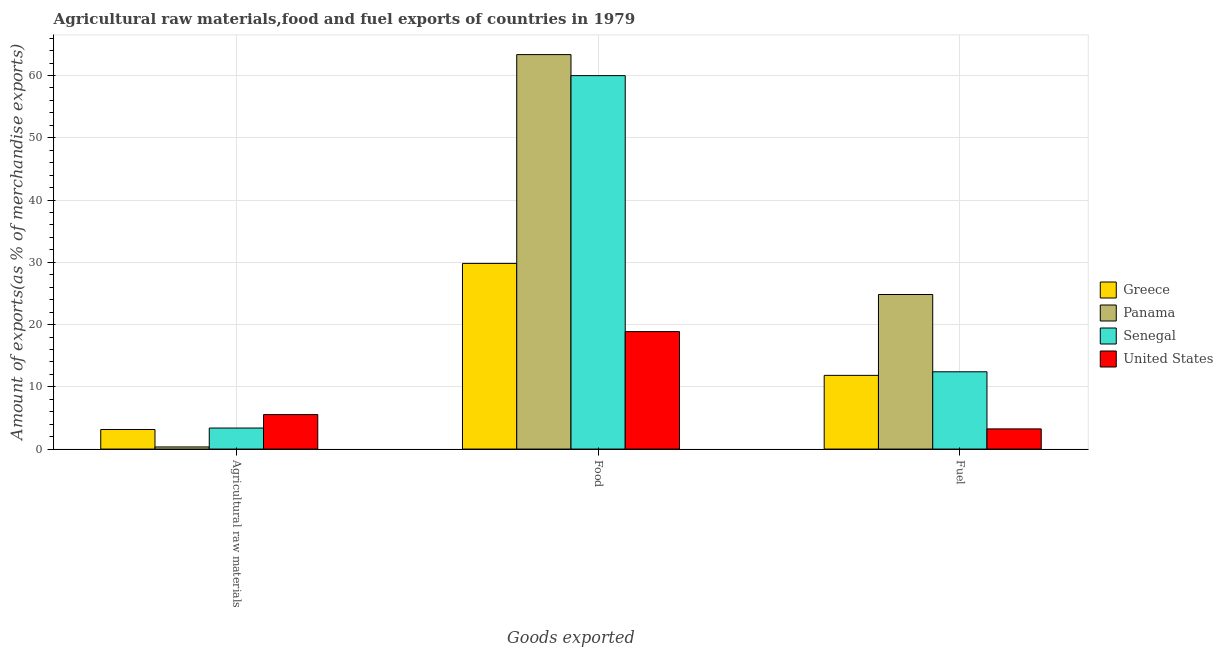How many different coloured bars are there?
Offer a very short reply. 4. Are the number of bars per tick equal to the number of legend labels?
Your answer should be compact. Yes. Are the number of bars on each tick of the X-axis equal?
Your answer should be compact. Yes. How many bars are there on the 2nd tick from the left?
Your answer should be very brief. 4. How many bars are there on the 3rd tick from the right?
Your answer should be compact. 4. What is the label of the 3rd group of bars from the left?
Provide a succinct answer. Fuel. What is the percentage of food exports in Greece?
Provide a short and direct response. 29.82. Across all countries, what is the maximum percentage of food exports?
Provide a short and direct response. 63.36. Across all countries, what is the minimum percentage of raw materials exports?
Offer a very short reply. 0.34. In which country was the percentage of fuel exports maximum?
Offer a very short reply. Panama. In which country was the percentage of food exports minimum?
Provide a succinct answer. United States. What is the total percentage of raw materials exports in the graph?
Keep it short and to the point. 12.4. What is the difference between the percentage of food exports in Panama and that in United States?
Keep it short and to the point. 44.49. What is the difference between the percentage of food exports in United States and the percentage of fuel exports in Greece?
Provide a succinct answer. 7.03. What is the average percentage of raw materials exports per country?
Give a very brief answer. 3.1. What is the difference between the percentage of fuel exports and percentage of raw materials exports in Greece?
Ensure brevity in your answer.  8.69. In how many countries, is the percentage of raw materials exports greater than 32 %?
Offer a very short reply. 0. What is the ratio of the percentage of raw materials exports in United States to that in Greece?
Make the answer very short. 1.76. Is the percentage of raw materials exports in Greece less than that in United States?
Offer a very short reply. Yes. What is the difference between the highest and the second highest percentage of fuel exports?
Your answer should be compact. 12.42. What is the difference between the highest and the lowest percentage of food exports?
Provide a short and direct response. 44.49. Is the sum of the percentage of fuel exports in Senegal and Greece greater than the maximum percentage of raw materials exports across all countries?
Provide a succinct answer. Yes. What does the 2nd bar from the left in Fuel represents?
Ensure brevity in your answer.  Panama. What does the 4th bar from the right in Fuel represents?
Your answer should be compact. Greece. How many countries are there in the graph?
Offer a very short reply. 4. Are the values on the major ticks of Y-axis written in scientific E-notation?
Provide a succinct answer. No. How are the legend labels stacked?
Provide a short and direct response. Vertical. What is the title of the graph?
Keep it short and to the point. Agricultural raw materials,food and fuel exports of countries in 1979. What is the label or title of the X-axis?
Your response must be concise. Goods exported. What is the label or title of the Y-axis?
Make the answer very short. Amount of exports(as % of merchandise exports). What is the Amount of exports(as % of merchandise exports) in Greece in Agricultural raw materials?
Your response must be concise. 3.14. What is the Amount of exports(as % of merchandise exports) of Panama in Agricultural raw materials?
Offer a very short reply. 0.34. What is the Amount of exports(as % of merchandise exports) in Senegal in Agricultural raw materials?
Your answer should be compact. 3.38. What is the Amount of exports(as % of merchandise exports) of United States in Agricultural raw materials?
Provide a short and direct response. 5.54. What is the Amount of exports(as % of merchandise exports) in Greece in Food?
Offer a terse response. 29.82. What is the Amount of exports(as % of merchandise exports) of Panama in Food?
Ensure brevity in your answer.  63.36. What is the Amount of exports(as % of merchandise exports) in Senegal in Food?
Ensure brevity in your answer.  59.98. What is the Amount of exports(as % of merchandise exports) of United States in Food?
Make the answer very short. 18.87. What is the Amount of exports(as % of merchandise exports) of Greece in Fuel?
Provide a succinct answer. 11.84. What is the Amount of exports(as % of merchandise exports) of Panama in Fuel?
Ensure brevity in your answer.  24.83. What is the Amount of exports(as % of merchandise exports) of Senegal in Fuel?
Keep it short and to the point. 12.41. What is the Amount of exports(as % of merchandise exports) in United States in Fuel?
Offer a terse response. 3.24. Across all Goods exported, what is the maximum Amount of exports(as % of merchandise exports) in Greece?
Provide a short and direct response. 29.82. Across all Goods exported, what is the maximum Amount of exports(as % of merchandise exports) of Panama?
Ensure brevity in your answer.  63.36. Across all Goods exported, what is the maximum Amount of exports(as % of merchandise exports) in Senegal?
Offer a terse response. 59.98. Across all Goods exported, what is the maximum Amount of exports(as % of merchandise exports) in United States?
Offer a very short reply. 18.87. Across all Goods exported, what is the minimum Amount of exports(as % of merchandise exports) of Greece?
Offer a very short reply. 3.14. Across all Goods exported, what is the minimum Amount of exports(as % of merchandise exports) of Panama?
Offer a terse response. 0.34. Across all Goods exported, what is the minimum Amount of exports(as % of merchandise exports) in Senegal?
Make the answer very short. 3.38. Across all Goods exported, what is the minimum Amount of exports(as % of merchandise exports) in United States?
Keep it short and to the point. 3.24. What is the total Amount of exports(as % of merchandise exports) of Greece in the graph?
Your answer should be very brief. 44.8. What is the total Amount of exports(as % of merchandise exports) of Panama in the graph?
Offer a very short reply. 88.53. What is the total Amount of exports(as % of merchandise exports) in Senegal in the graph?
Ensure brevity in your answer.  75.78. What is the total Amount of exports(as % of merchandise exports) in United States in the graph?
Your response must be concise. 27.65. What is the difference between the Amount of exports(as % of merchandise exports) of Greece in Agricultural raw materials and that in Food?
Offer a terse response. -26.68. What is the difference between the Amount of exports(as % of merchandise exports) of Panama in Agricultural raw materials and that in Food?
Provide a succinct answer. -63.02. What is the difference between the Amount of exports(as % of merchandise exports) in Senegal in Agricultural raw materials and that in Food?
Provide a succinct answer. -56.61. What is the difference between the Amount of exports(as % of merchandise exports) in United States in Agricultural raw materials and that in Food?
Give a very brief answer. -13.33. What is the difference between the Amount of exports(as % of merchandise exports) of Greece in Agricultural raw materials and that in Fuel?
Provide a succinct answer. -8.69. What is the difference between the Amount of exports(as % of merchandise exports) of Panama in Agricultural raw materials and that in Fuel?
Offer a terse response. -24.49. What is the difference between the Amount of exports(as % of merchandise exports) of Senegal in Agricultural raw materials and that in Fuel?
Provide a succinct answer. -9.04. What is the difference between the Amount of exports(as % of merchandise exports) of United States in Agricultural raw materials and that in Fuel?
Provide a succinct answer. 2.3. What is the difference between the Amount of exports(as % of merchandise exports) in Greece in Food and that in Fuel?
Your answer should be compact. 17.98. What is the difference between the Amount of exports(as % of merchandise exports) in Panama in Food and that in Fuel?
Provide a succinct answer. 38.53. What is the difference between the Amount of exports(as % of merchandise exports) in Senegal in Food and that in Fuel?
Your answer should be very brief. 47.57. What is the difference between the Amount of exports(as % of merchandise exports) of United States in Food and that in Fuel?
Offer a terse response. 15.63. What is the difference between the Amount of exports(as % of merchandise exports) in Greece in Agricultural raw materials and the Amount of exports(as % of merchandise exports) in Panama in Food?
Provide a succinct answer. -60.22. What is the difference between the Amount of exports(as % of merchandise exports) of Greece in Agricultural raw materials and the Amount of exports(as % of merchandise exports) of Senegal in Food?
Your answer should be compact. -56.84. What is the difference between the Amount of exports(as % of merchandise exports) of Greece in Agricultural raw materials and the Amount of exports(as % of merchandise exports) of United States in Food?
Offer a very short reply. -15.72. What is the difference between the Amount of exports(as % of merchandise exports) in Panama in Agricultural raw materials and the Amount of exports(as % of merchandise exports) in Senegal in Food?
Provide a short and direct response. -59.64. What is the difference between the Amount of exports(as % of merchandise exports) of Panama in Agricultural raw materials and the Amount of exports(as % of merchandise exports) of United States in Food?
Your response must be concise. -18.53. What is the difference between the Amount of exports(as % of merchandise exports) in Senegal in Agricultural raw materials and the Amount of exports(as % of merchandise exports) in United States in Food?
Provide a short and direct response. -15.49. What is the difference between the Amount of exports(as % of merchandise exports) of Greece in Agricultural raw materials and the Amount of exports(as % of merchandise exports) of Panama in Fuel?
Your answer should be very brief. -21.69. What is the difference between the Amount of exports(as % of merchandise exports) of Greece in Agricultural raw materials and the Amount of exports(as % of merchandise exports) of Senegal in Fuel?
Give a very brief answer. -9.27. What is the difference between the Amount of exports(as % of merchandise exports) of Greece in Agricultural raw materials and the Amount of exports(as % of merchandise exports) of United States in Fuel?
Your answer should be compact. -0.1. What is the difference between the Amount of exports(as % of merchandise exports) of Panama in Agricultural raw materials and the Amount of exports(as % of merchandise exports) of Senegal in Fuel?
Ensure brevity in your answer.  -12.07. What is the difference between the Amount of exports(as % of merchandise exports) of Panama in Agricultural raw materials and the Amount of exports(as % of merchandise exports) of United States in Fuel?
Offer a terse response. -2.9. What is the difference between the Amount of exports(as % of merchandise exports) in Senegal in Agricultural raw materials and the Amount of exports(as % of merchandise exports) in United States in Fuel?
Offer a terse response. 0.14. What is the difference between the Amount of exports(as % of merchandise exports) of Greece in Food and the Amount of exports(as % of merchandise exports) of Panama in Fuel?
Offer a very short reply. 4.99. What is the difference between the Amount of exports(as % of merchandise exports) in Greece in Food and the Amount of exports(as % of merchandise exports) in Senegal in Fuel?
Ensure brevity in your answer.  17.41. What is the difference between the Amount of exports(as % of merchandise exports) in Greece in Food and the Amount of exports(as % of merchandise exports) in United States in Fuel?
Make the answer very short. 26.58. What is the difference between the Amount of exports(as % of merchandise exports) in Panama in Food and the Amount of exports(as % of merchandise exports) in Senegal in Fuel?
Ensure brevity in your answer.  50.95. What is the difference between the Amount of exports(as % of merchandise exports) of Panama in Food and the Amount of exports(as % of merchandise exports) of United States in Fuel?
Your answer should be very brief. 60.12. What is the difference between the Amount of exports(as % of merchandise exports) in Senegal in Food and the Amount of exports(as % of merchandise exports) in United States in Fuel?
Your response must be concise. 56.74. What is the average Amount of exports(as % of merchandise exports) of Greece per Goods exported?
Offer a terse response. 14.93. What is the average Amount of exports(as % of merchandise exports) in Panama per Goods exported?
Make the answer very short. 29.51. What is the average Amount of exports(as % of merchandise exports) of Senegal per Goods exported?
Ensure brevity in your answer.  25.26. What is the average Amount of exports(as % of merchandise exports) of United States per Goods exported?
Your response must be concise. 9.22. What is the difference between the Amount of exports(as % of merchandise exports) of Greece and Amount of exports(as % of merchandise exports) of Panama in Agricultural raw materials?
Offer a terse response. 2.8. What is the difference between the Amount of exports(as % of merchandise exports) in Greece and Amount of exports(as % of merchandise exports) in Senegal in Agricultural raw materials?
Your answer should be compact. -0.23. What is the difference between the Amount of exports(as % of merchandise exports) of Greece and Amount of exports(as % of merchandise exports) of United States in Agricultural raw materials?
Ensure brevity in your answer.  -2.39. What is the difference between the Amount of exports(as % of merchandise exports) of Panama and Amount of exports(as % of merchandise exports) of Senegal in Agricultural raw materials?
Give a very brief answer. -3.04. What is the difference between the Amount of exports(as % of merchandise exports) of Panama and Amount of exports(as % of merchandise exports) of United States in Agricultural raw materials?
Offer a terse response. -5.2. What is the difference between the Amount of exports(as % of merchandise exports) in Senegal and Amount of exports(as % of merchandise exports) in United States in Agricultural raw materials?
Your answer should be very brief. -2.16. What is the difference between the Amount of exports(as % of merchandise exports) in Greece and Amount of exports(as % of merchandise exports) in Panama in Food?
Your answer should be very brief. -33.54. What is the difference between the Amount of exports(as % of merchandise exports) in Greece and Amount of exports(as % of merchandise exports) in Senegal in Food?
Offer a terse response. -30.16. What is the difference between the Amount of exports(as % of merchandise exports) of Greece and Amount of exports(as % of merchandise exports) of United States in Food?
Your response must be concise. 10.95. What is the difference between the Amount of exports(as % of merchandise exports) in Panama and Amount of exports(as % of merchandise exports) in Senegal in Food?
Keep it short and to the point. 3.38. What is the difference between the Amount of exports(as % of merchandise exports) of Panama and Amount of exports(as % of merchandise exports) of United States in Food?
Make the answer very short. 44.49. What is the difference between the Amount of exports(as % of merchandise exports) in Senegal and Amount of exports(as % of merchandise exports) in United States in Food?
Your answer should be compact. 41.12. What is the difference between the Amount of exports(as % of merchandise exports) of Greece and Amount of exports(as % of merchandise exports) of Panama in Fuel?
Ensure brevity in your answer.  -12.99. What is the difference between the Amount of exports(as % of merchandise exports) in Greece and Amount of exports(as % of merchandise exports) in Senegal in Fuel?
Your response must be concise. -0.58. What is the difference between the Amount of exports(as % of merchandise exports) of Greece and Amount of exports(as % of merchandise exports) of United States in Fuel?
Give a very brief answer. 8.6. What is the difference between the Amount of exports(as % of merchandise exports) of Panama and Amount of exports(as % of merchandise exports) of Senegal in Fuel?
Make the answer very short. 12.42. What is the difference between the Amount of exports(as % of merchandise exports) of Panama and Amount of exports(as % of merchandise exports) of United States in Fuel?
Your response must be concise. 21.59. What is the difference between the Amount of exports(as % of merchandise exports) of Senegal and Amount of exports(as % of merchandise exports) of United States in Fuel?
Offer a terse response. 9.17. What is the ratio of the Amount of exports(as % of merchandise exports) in Greece in Agricultural raw materials to that in Food?
Give a very brief answer. 0.11. What is the ratio of the Amount of exports(as % of merchandise exports) of Panama in Agricultural raw materials to that in Food?
Offer a very short reply. 0.01. What is the ratio of the Amount of exports(as % of merchandise exports) of Senegal in Agricultural raw materials to that in Food?
Provide a succinct answer. 0.06. What is the ratio of the Amount of exports(as % of merchandise exports) in United States in Agricultural raw materials to that in Food?
Offer a terse response. 0.29. What is the ratio of the Amount of exports(as % of merchandise exports) of Greece in Agricultural raw materials to that in Fuel?
Your response must be concise. 0.27. What is the ratio of the Amount of exports(as % of merchandise exports) of Panama in Agricultural raw materials to that in Fuel?
Your answer should be compact. 0.01. What is the ratio of the Amount of exports(as % of merchandise exports) in Senegal in Agricultural raw materials to that in Fuel?
Ensure brevity in your answer.  0.27. What is the ratio of the Amount of exports(as % of merchandise exports) of United States in Agricultural raw materials to that in Fuel?
Your response must be concise. 1.71. What is the ratio of the Amount of exports(as % of merchandise exports) of Greece in Food to that in Fuel?
Your answer should be very brief. 2.52. What is the ratio of the Amount of exports(as % of merchandise exports) of Panama in Food to that in Fuel?
Give a very brief answer. 2.55. What is the ratio of the Amount of exports(as % of merchandise exports) of Senegal in Food to that in Fuel?
Offer a very short reply. 4.83. What is the ratio of the Amount of exports(as % of merchandise exports) in United States in Food to that in Fuel?
Provide a short and direct response. 5.82. What is the difference between the highest and the second highest Amount of exports(as % of merchandise exports) in Greece?
Provide a short and direct response. 17.98. What is the difference between the highest and the second highest Amount of exports(as % of merchandise exports) in Panama?
Provide a short and direct response. 38.53. What is the difference between the highest and the second highest Amount of exports(as % of merchandise exports) of Senegal?
Keep it short and to the point. 47.57. What is the difference between the highest and the second highest Amount of exports(as % of merchandise exports) in United States?
Ensure brevity in your answer.  13.33. What is the difference between the highest and the lowest Amount of exports(as % of merchandise exports) of Greece?
Your answer should be compact. 26.68. What is the difference between the highest and the lowest Amount of exports(as % of merchandise exports) in Panama?
Your answer should be compact. 63.02. What is the difference between the highest and the lowest Amount of exports(as % of merchandise exports) in Senegal?
Provide a short and direct response. 56.61. What is the difference between the highest and the lowest Amount of exports(as % of merchandise exports) of United States?
Your answer should be compact. 15.63. 